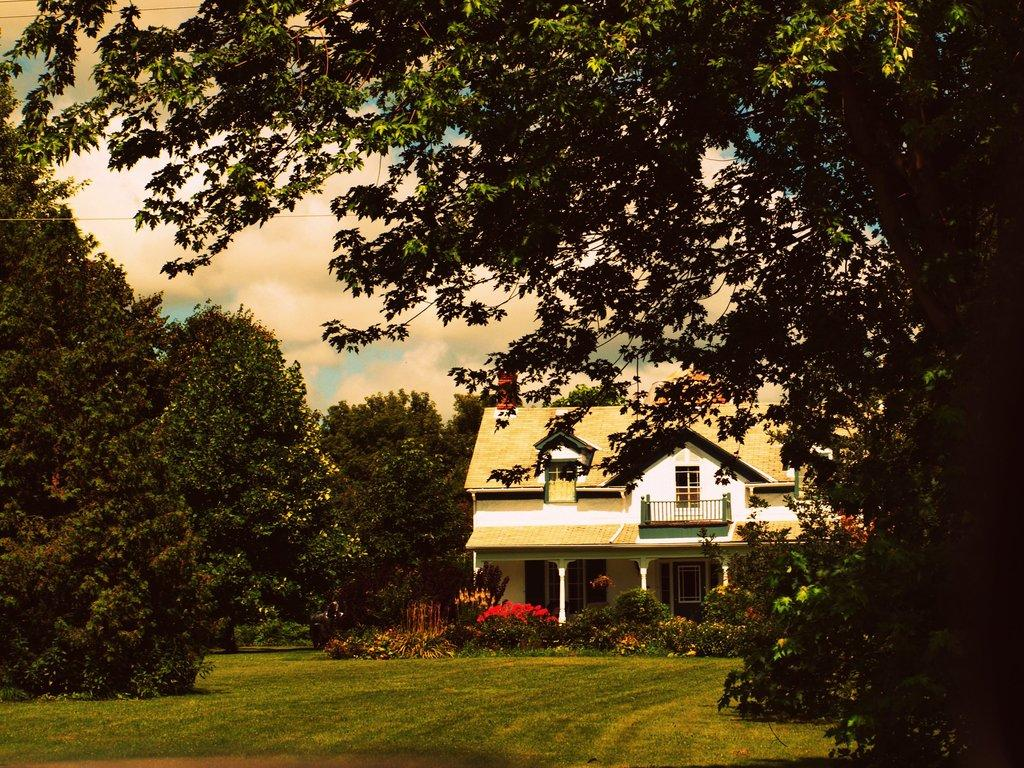What type of structure is in the picture? There is a building in the picture. What features can be seen on the building? The building has doors and windows. What other elements are present in the picture besides the building? There are plants and trees on both the right and left sides of the picture. What is the condition of the sky in the picture? The sky is clear in the picture. Can you tell me how many desks are visible in the picture? There are no desks present in the image; it features a building with doors and windows, surrounded by plants and trees. What type of bird is perched on the wheel in the picture? There is no wheel or bird present in the image. 